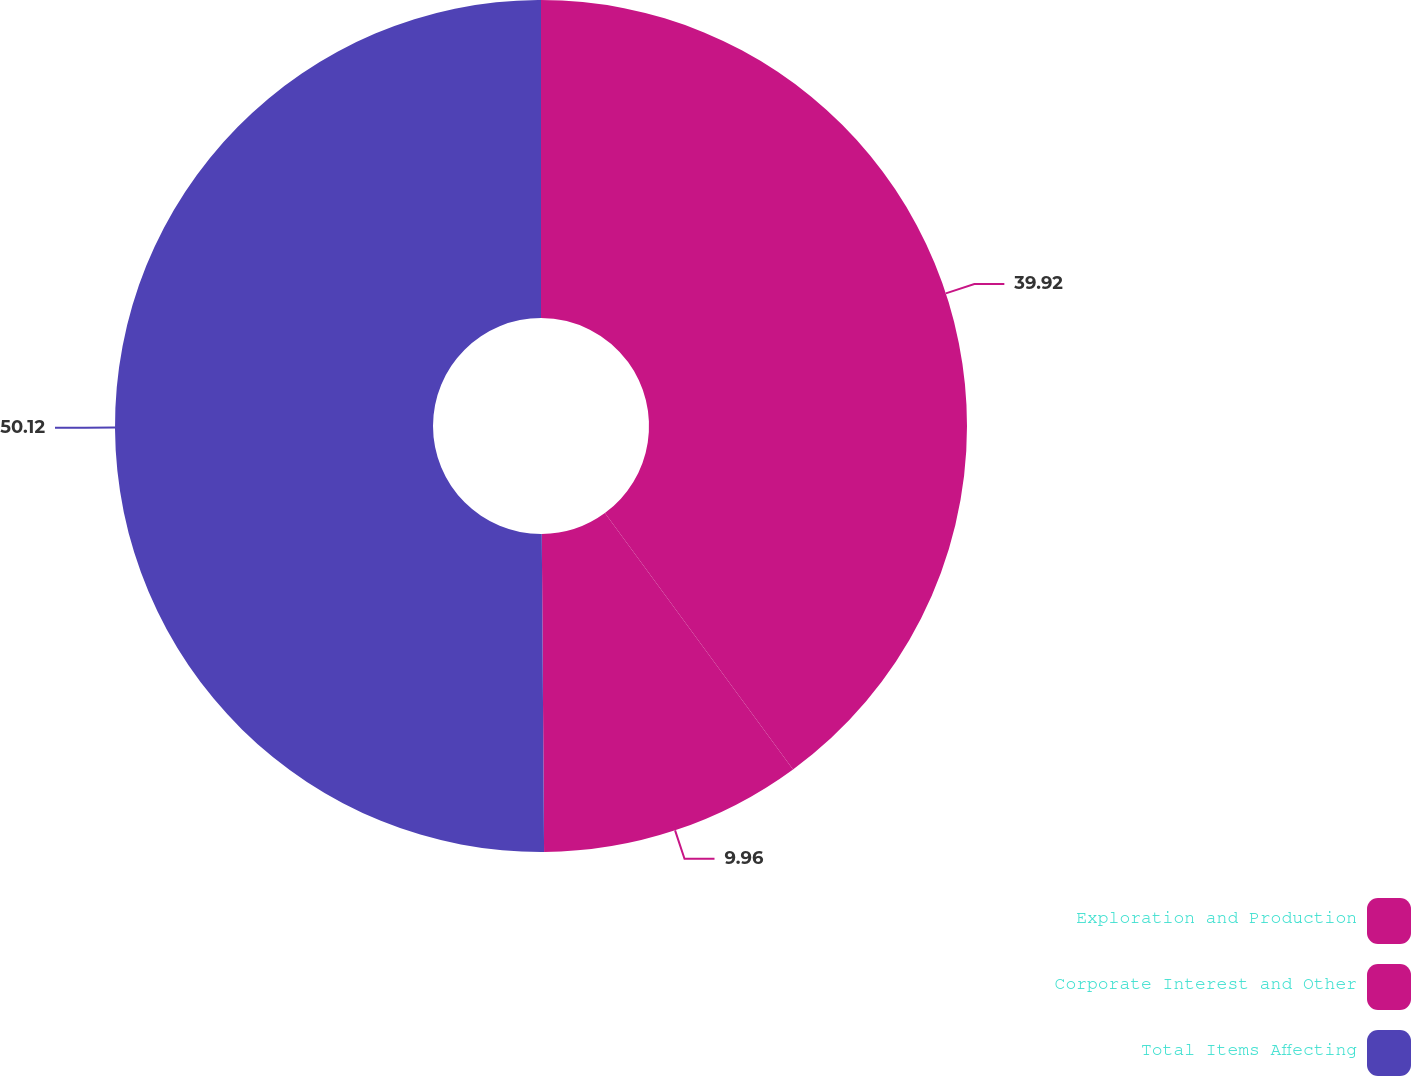Convert chart to OTSL. <chart><loc_0><loc_0><loc_500><loc_500><pie_chart><fcel>Exploration and Production<fcel>Corporate Interest and Other<fcel>Total Items Affecting<nl><fcel>39.92%<fcel>9.96%<fcel>50.11%<nl></chart> 